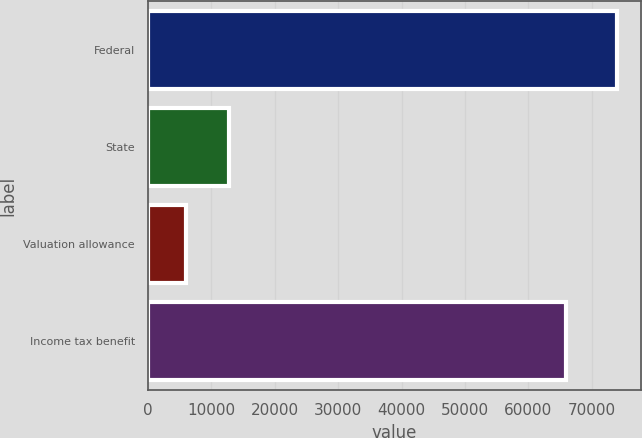Convert chart to OTSL. <chart><loc_0><loc_0><loc_500><loc_500><bar_chart><fcel>Federal<fcel>State<fcel>Valuation allowance<fcel>Income tax benefit<nl><fcel>74029<fcel>12791.2<fcel>5987<fcel>65897<nl></chart> 